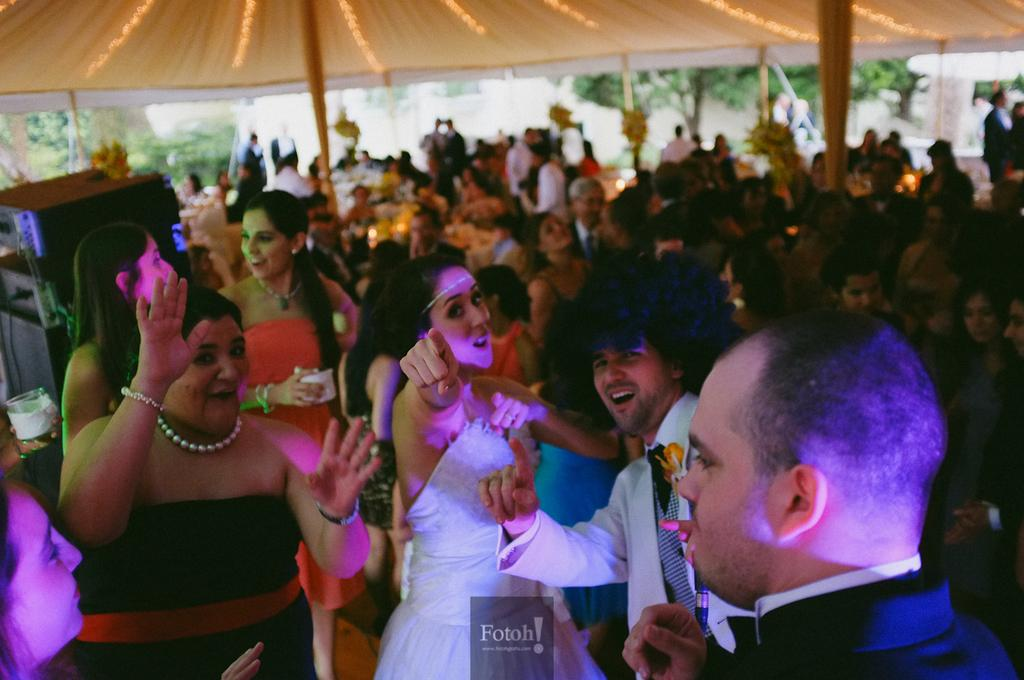Who is present in the image? There are people in the image. What are the people doing in the image? The people are dancing. Can you describe the setting of the image? The setting appears to be a party. What type of structure can be seen in the background of the image? There is no structure visible in the background of the image. Can you describe the feathers used in the dancers' costumes in the image? There are no feathers mentioned or visible in the image; the people are simply dancing. 